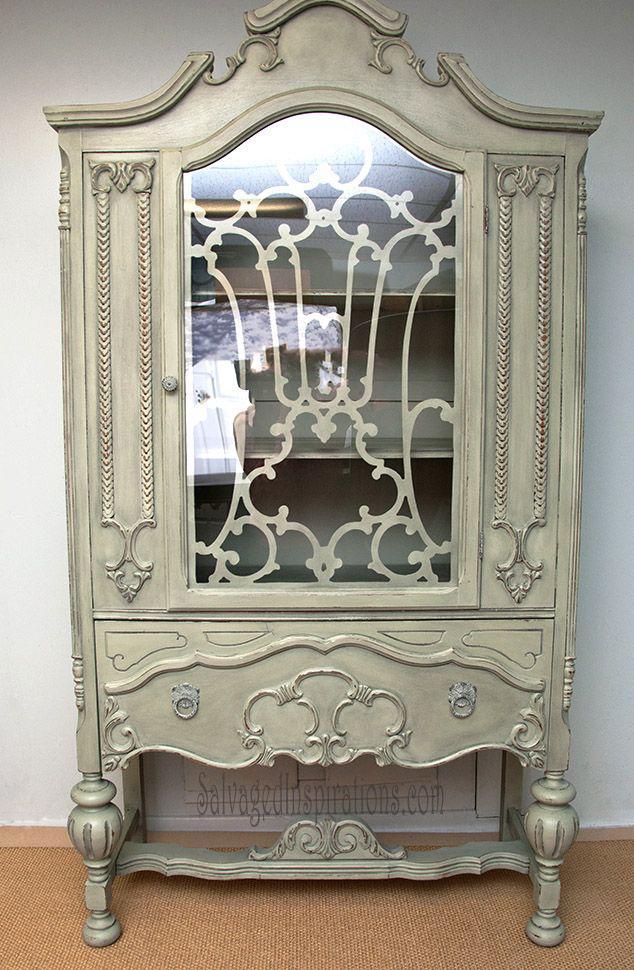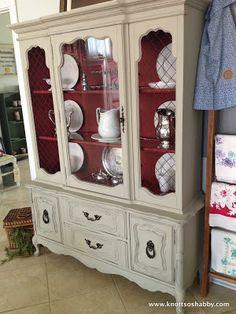The first image is the image on the left, the second image is the image on the right. Examine the images to the left and right. Is the description "A wooden hutch with three rows of dishes in its upper section has at least two drawers with pulls between doors in the bottom section." accurate? Answer yes or no. Yes. The first image is the image on the left, the second image is the image on the right. Given the left and right images, does the statement "At least one of the cabinets has an arched top as well as some type of legs." hold true? Answer yes or no. Yes. 